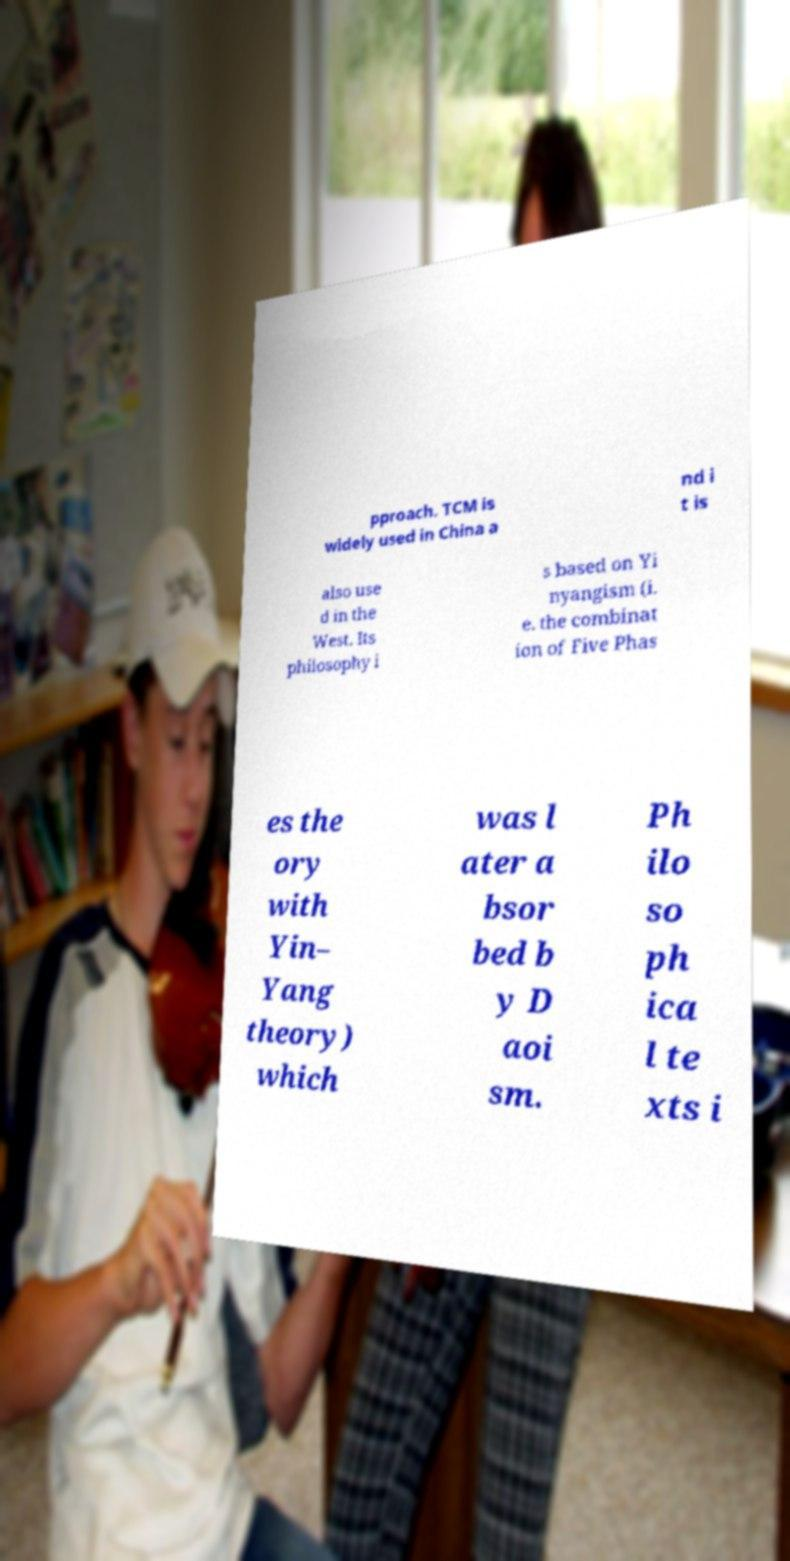Can you accurately transcribe the text from the provided image for me? pproach. TCM is widely used in China a nd i t is also use d in the West. Its philosophy i s based on Yi nyangism (i. e. the combinat ion of Five Phas es the ory with Yin– Yang theory) which was l ater a bsor bed b y D aoi sm. Ph ilo so ph ica l te xts i 